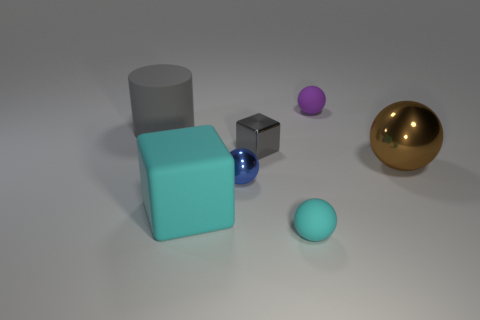Subtract all tiny purple rubber spheres. How many spheres are left? 3 Subtract 2 balls. How many balls are left? 2 Add 1 big brown things. How many objects exist? 8 Subtract all cyan blocks. How many blocks are left? 1 Subtract 0 red cylinders. How many objects are left? 7 Subtract all cylinders. How many objects are left? 6 Subtract all cyan cylinders. Subtract all green spheres. How many cylinders are left? 1 Subtract all gray cubes. Subtract all gray matte cylinders. How many objects are left? 5 Add 1 big rubber cubes. How many big rubber cubes are left? 2 Add 4 tiny metal spheres. How many tiny metal spheres exist? 5 